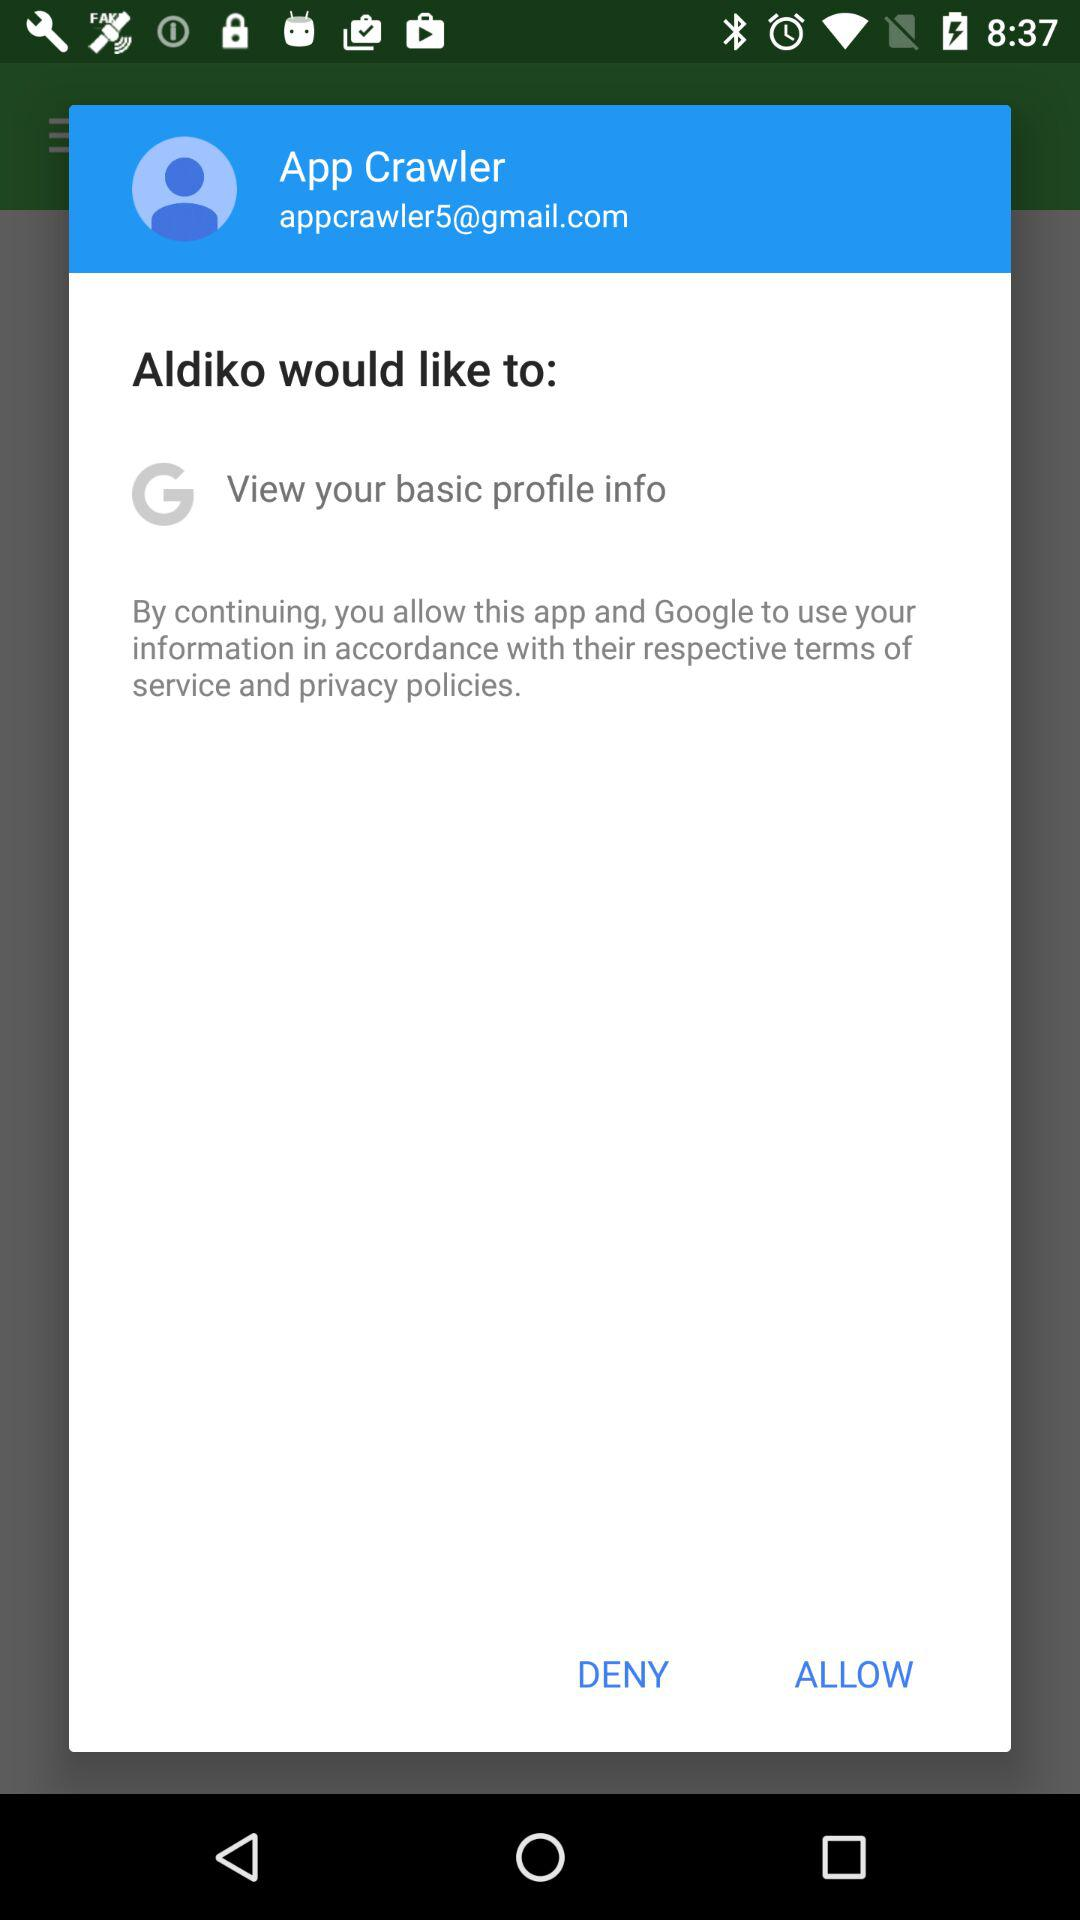What is the email address? The email address is appcrawler5@gmail.com. 